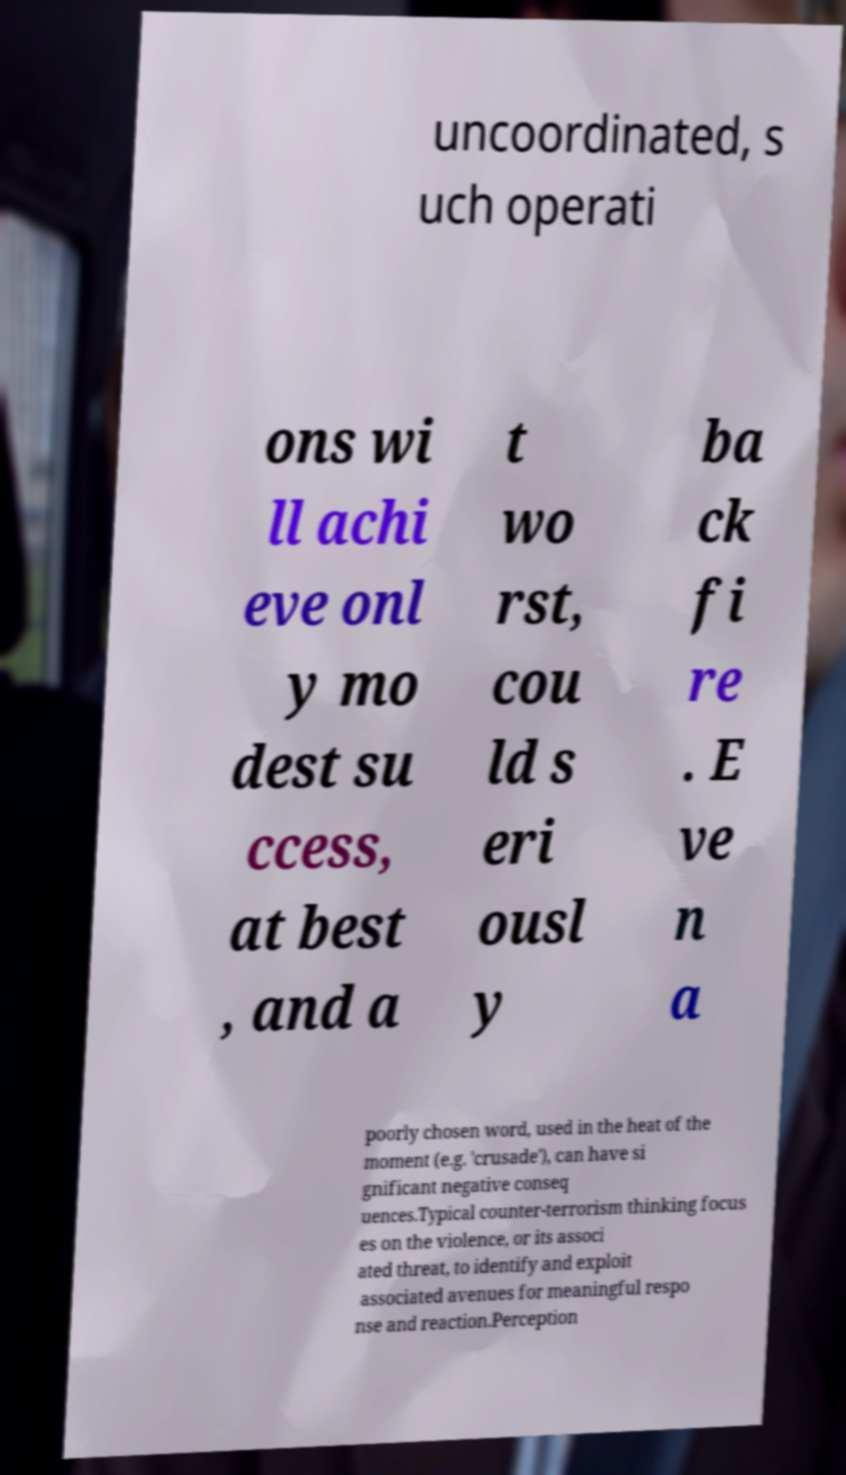Can you accurately transcribe the text from the provided image for me? uncoordinated, s uch operati ons wi ll achi eve onl y mo dest su ccess, at best , and a t wo rst, cou ld s eri ousl y ba ck fi re . E ve n a poorly chosen word, used in the heat of the moment (e.g. 'crusade'), can have si gnificant negative conseq uences.Typical counter-terrorism thinking focus es on the violence, or its associ ated threat, to identify and exploit associated avenues for meaningful respo nse and reaction.Perception 